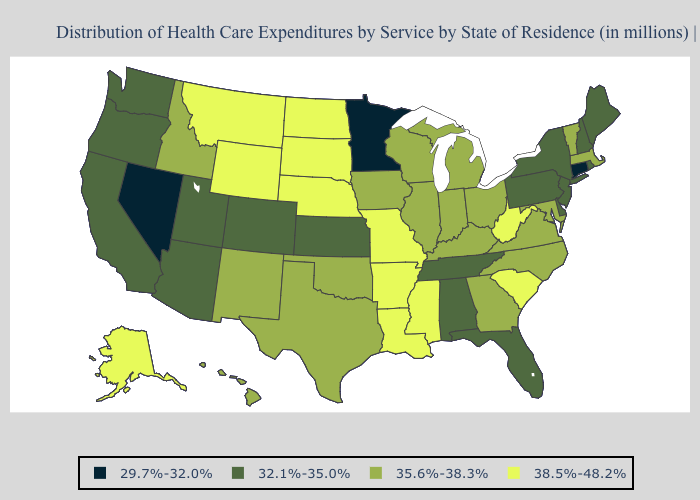Name the states that have a value in the range 35.6%-38.3%?
Write a very short answer. Georgia, Hawaii, Idaho, Illinois, Indiana, Iowa, Kentucky, Maryland, Massachusetts, Michigan, New Mexico, North Carolina, Ohio, Oklahoma, Texas, Vermont, Virginia, Wisconsin. Name the states that have a value in the range 29.7%-32.0%?
Answer briefly. Connecticut, Minnesota, Nevada. Does Wyoming have the lowest value in the West?
Answer briefly. No. Name the states that have a value in the range 35.6%-38.3%?
Give a very brief answer. Georgia, Hawaii, Idaho, Illinois, Indiana, Iowa, Kentucky, Maryland, Massachusetts, Michigan, New Mexico, North Carolina, Ohio, Oklahoma, Texas, Vermont, Virginia, Wisconsin. Name the states that have a value in the range 32.1%-35.0%?
Give a very brief answer. Alabama, Arizona, California, Colorado, Delaware, Florida, Kansas, Maine, New Hampshire, New Jersey, New York, Oregon, Pennsylvania, Rhode Island, Tennessee, Utah, Washington. What is the value of Oklahoma?
Quick response, please. 35.6%-38.3%. Which states hav the highest value in the South?
Concise answer only. Arkansas, Louisiana, Mississippi, South Carolina, West Virginia. Does Georgia have a lower value than Louisiana?
Concise answer only. Yes. Name the states that have a value in the range 32.1%-35.0%?
Concise answer only. Alabama, Arizona, California, Colorado, Delaware, Florida, Kansas, Maine, New Hampshire, New Jersey, New York, Oregon, Pennsylvania, Rhode Island, Tennessee, Utah, Washington. Is the legend a continuous bar?
Give a very brief answer. No. What is the value of Colorado?
Answer briefly. 32.1%-35.0%. Among the states that border Georgia , does Alabama have the lowest value?
Give a very brief answer. Yes. Name the states that have a value in the range 32.1%-35.0%?
Give a very brief answer. Alabama, Arizona, California, Colorado, Delaware, Florida, Kansas, Maine, New Hampshire, New Jersey, New York, Oregon, Pennsylvania, Rhode Island, Tennessee, Utah, Washington. What is the value of Idaho?
Keep it brief. 35.6%-38.3%. Name the states that have a value in the range 32.1%-35.0%?
Short answer required. Alabama, Arizona, California, Colorado, Delaware, Florida, Kansas, Maine, New Hampshire, New Jersey, New York, Oregon, Pennsylvania, Rhode Island, Tennessee, Utah, Washington. 